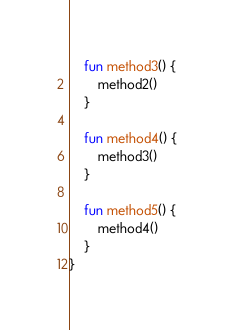Convert code to text. <code><loc_0><loc_0><loc_500><loc_500><_Kotlin_>
    fun method3() {
        method2()
    }

    fun method4() {
        method3()
    }

    fun method5() {
        method4()
    }
}
</code> 